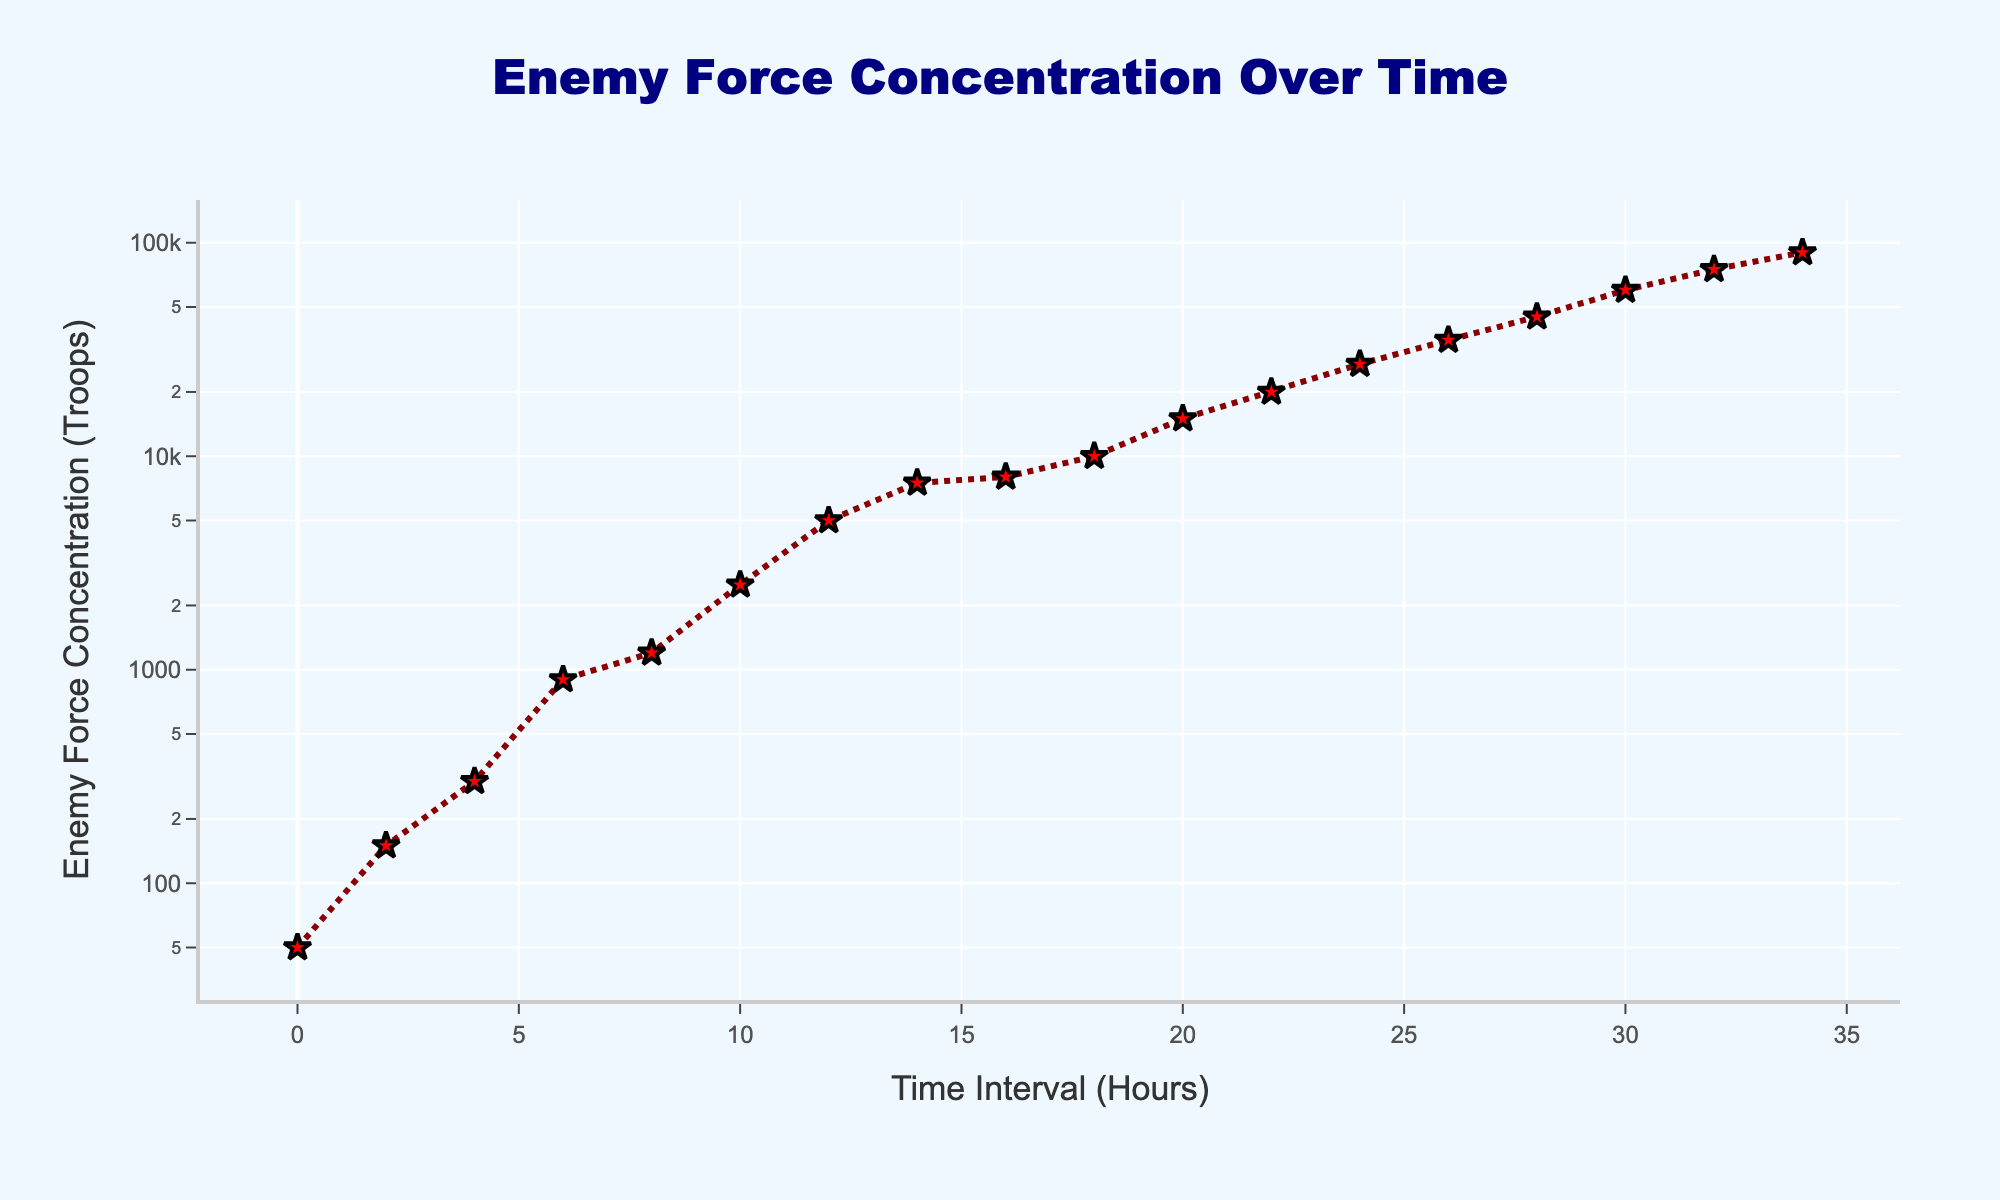How many time intervals are represented in the plot? Count the number of data points along the x-axis, which represent the time intervals. Each point corresponds to a distinct interval.
Answer: 18 What is the title of the plot? The title is usually found at the top of the plot.
Answer: Enemy Force Concentration Over Time At what time interval does the enemy force concentration first surpass 10,000 troops? Look at the y-axis for the value 10,000 troops and trace it horizontally to the corresponding x-axis time interval.
Answer: 18 hours How many annotations are present in the plot? Look for any text or markers that provide extra information about specific datapoints.
Answer: 1 What is the color of the markers used to represent enemy force concentrations? Observe the color of the markers (stars) in the plot.
Answer: Red Between which two time intervals does the enemy force concentration increase the most rapidly? Identify the steepest part of the plot based on the slopes of the segments between consecutive data points. The plot points between this steep section will give you the time intervals.
Answer: 0 to 10 hours How much does the enemy force concentration increase from 6 hours to 18 hours? Subtract the concentration at 6 hours from the concentration at 18 hours: \(10,000 - 900 = 9,100\).
Answer: 9,100 troops What is the highest enemy force concentration reported, and at what time interval does it occur? Locate the maximum value on the y-axis and the corresponding x-axis interval.
Answer: 90,000 troops at 34 hours How does the increase in enemy force concentration between 0 to 4 hours compare to the increase between 10 to 14 hours? Calculate the increases for both intervals and compare the values: \(300 - 50 = 250\) and \(7,500 - 2,500 = 5,000\). The latter has a greater increase.
Answer: The increase from 10 to 14 hours is significantly larger Why might the y-axis be set to a logarithmic scale? A logarithmic scale can help visualize data that covers a wide range of values by compressing the scale, making it easier to see variations at lower and higher ranges. This is useful for showing both small and large concentrations without losing detail.
Answer: To visualize the wide range of enemy concentrations more clearly 